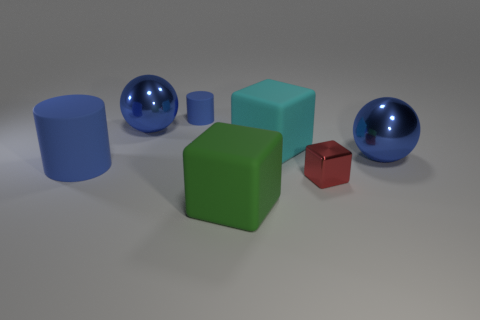Subtract all red shiny blocks. How many blocks are left? 2 Subtract all green cubes. How many cubes are left? 2 Add 5 small metal things. How many small metal things are left? 6 Add 7 blue spheres. How many blue spheres exist? 9 Add 3 big green rubber blocks. How many objects exist? 10 Subtract 0 cyan balls. How many objects are left? 7 Subtract all spheres. How many objects are left? 5 Subtract 1 blocks. How many blocks are left? 2 Subtract all purple cylinders. Subtract all yellow cubes. How many cylinders are left? 2 Subtract all blue cubes. How many red cylinders are left? 0 